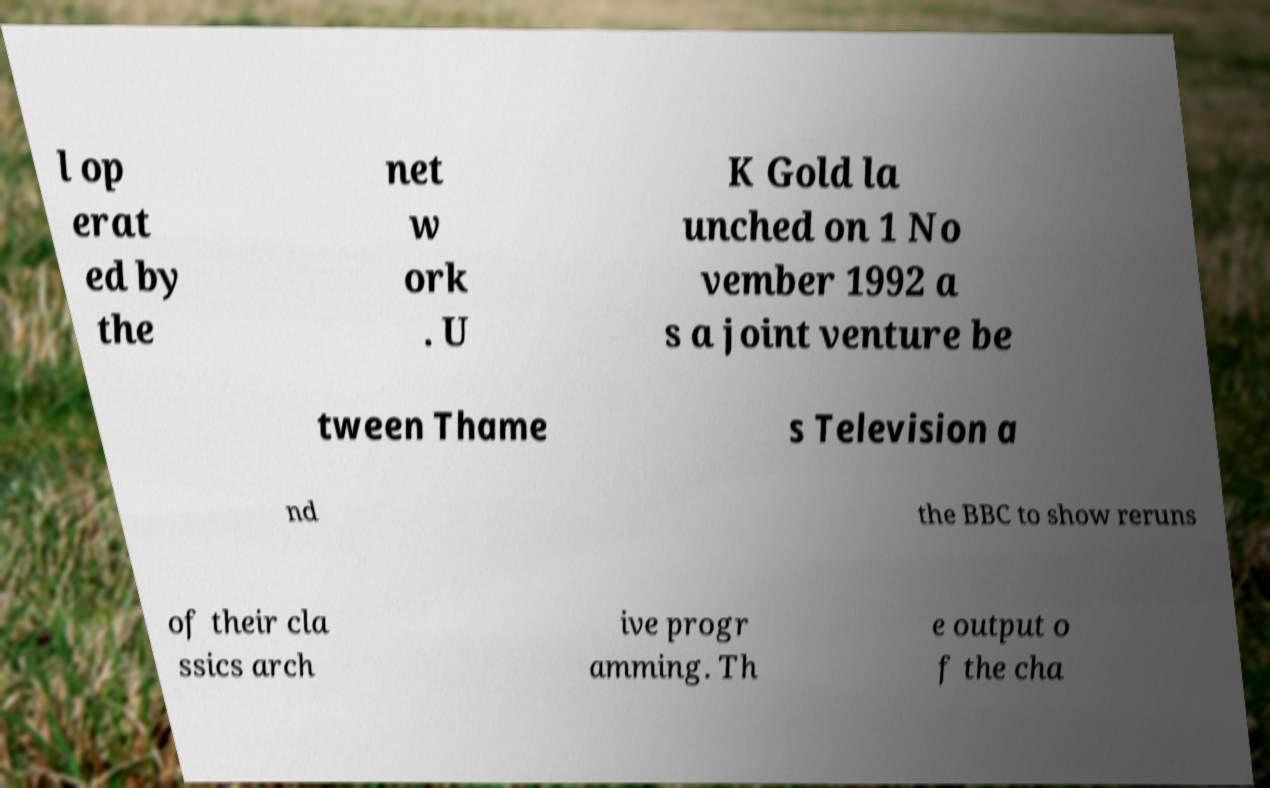Please identify and transcribe the text found in this image. l op erat ed by the net w ork . U K Gold la unched on 1 No vember 1992 a s a joint venture be tween Thame s Television a nd the BBC to show reruns of their cla ssics arch ive progr amming. Th e output o f the cha 